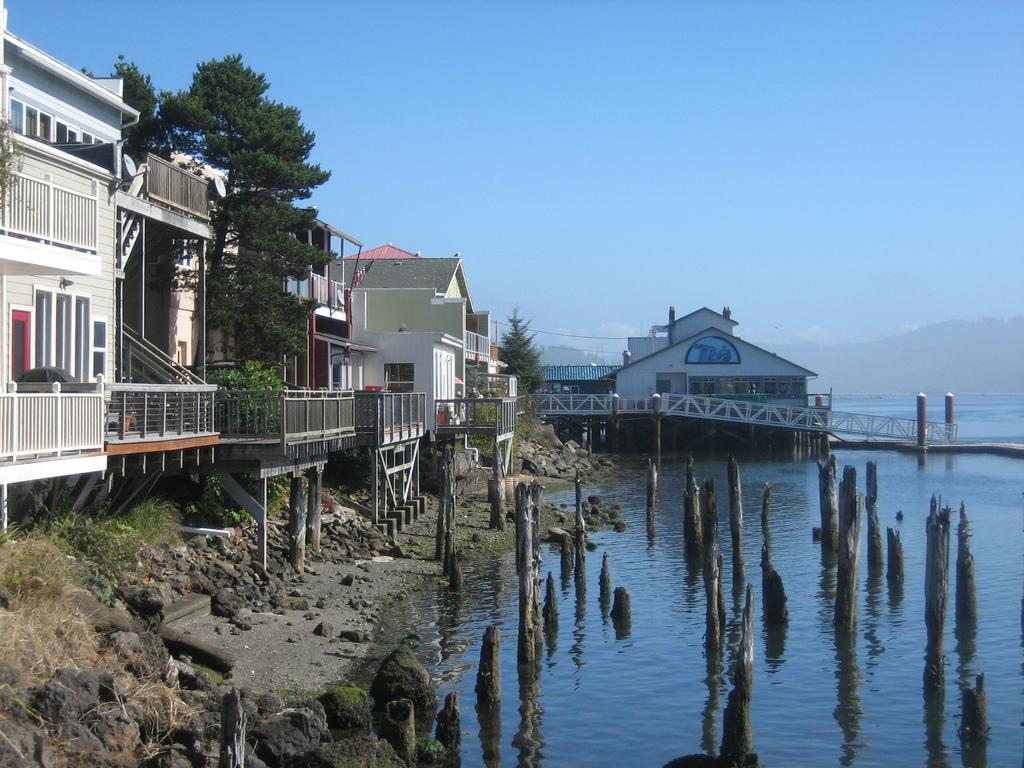How would you summarize this image in a sentence or two? In this image I can see the water, I can see few wooden sticks inside the water. Background I can see few buildings in white, cream and blue color, trees in green color and the sky is in blue color. 